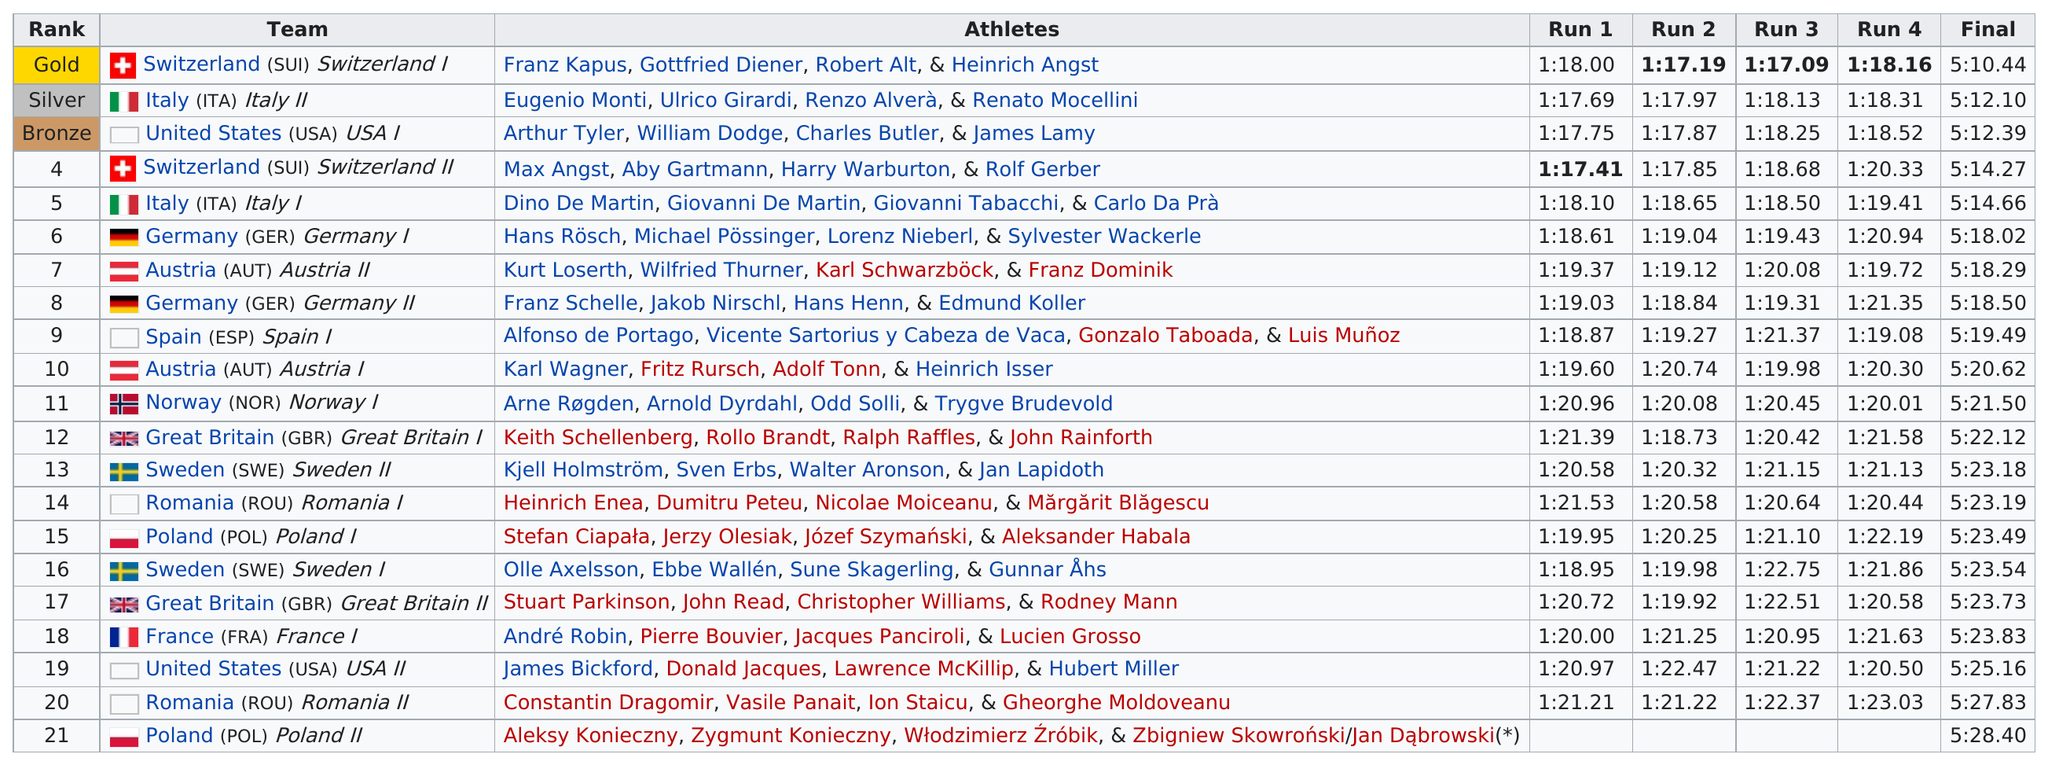Identify some key points in this picture. Switzerland achieved four consecutive runs under 1:19. The previous team to Italy (ITA) Italy II is Switzerland (SUI) Switzerland I. The highest-placing country is Italy. The difference between Austria's first and second run time is 0.25. The team that came in second to last place was Romania. 